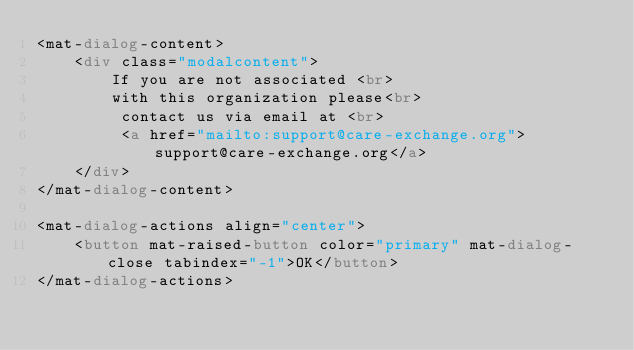Convert code to text. <code><loc_0><loc_0><loc_500><loc_500><_HTML_><mat-dialog-content>
    <div class="modalcontent">
        If you are not associated <br>
        with this organization please<br>
         contact us via email at <br>
         <a href="mailto:support@care-exchange.org">support@care-exchange.org</a>
    </div>
</mat-dialog-content>

<mat-dialog-actions align="center">
	<button mat-raised-button color="primary" mat-dialog-close tabindex="-1">OK</button>
</mat-dialog-actions></code> 